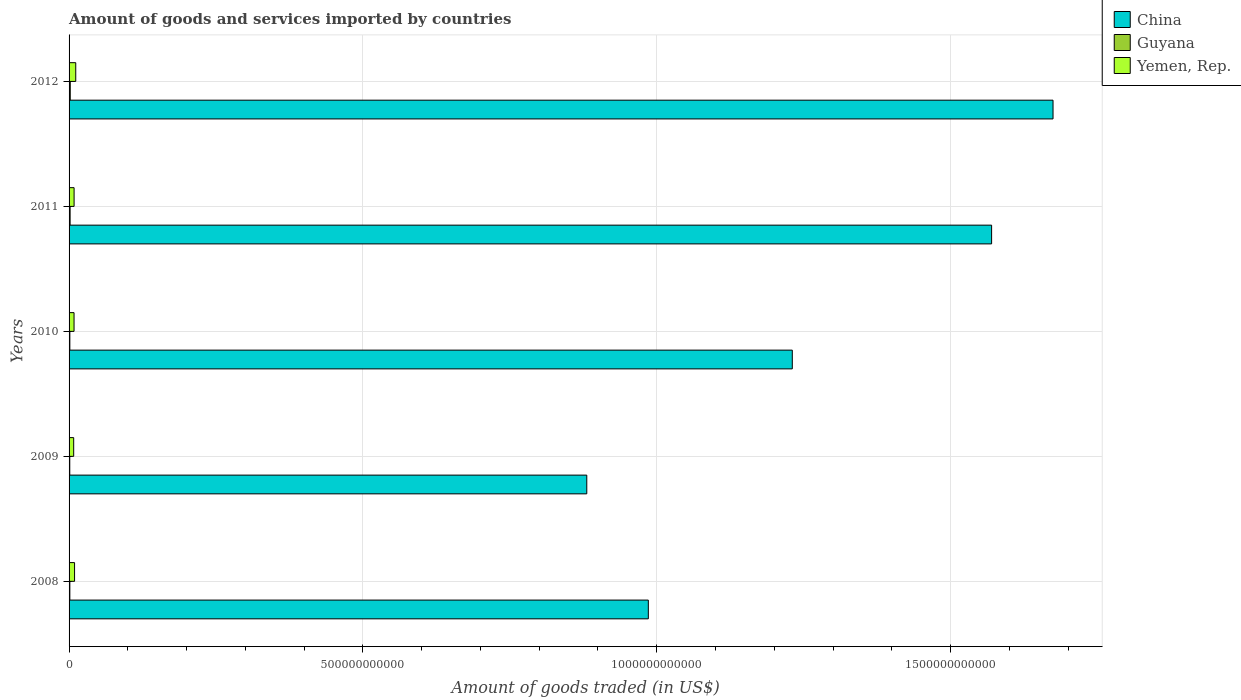Are the number of bars per tick equal to the number of legend labels?
Offer a terse response. Yes. How many bars are there on the 5th tick from the bottom?
Give a very brief answer. 3. What is the total amount of goods and services imported in Guyana in 2012?
Your response must be concise. 2.00e+09. Across all years, what is the maximum total amount of goods and services imported in Guyana?
Your answer should be compact. 2.00e+09. Across all years, what is the minimum total amount of goods and services imported in Guyana?
Make the answer very short. 1.18e+09. In which year was the total amount of goods and services imported in China maximum?
Ensure brevity in your answer.  2012. In which year was the total amount of goods and services imported in China minimum?
Provide a succinct answer. 2009. What is the total total amount of goods and services imported in China in the graph?
Ensure brevity in your answer.  6.34e+12. What is the difference between the total amount of goods and services imported in Yemen, Rep. in 2011 and that in 2012?
Ensure brevity in your answer.  -2.81e+09. What is the difference between the total amount of goods and services imported in Guyana in 2009 and the total amount of goods and services imported in China in 2011?
Your answer should be very brief. -1.57e+12. What is the average total amount of goods and services imported in China per year?
Make the answer very short. 1.27e+12. In the year 2010, what is the difference between the total amount of goods and services imported in China and total amount of goods and services imported in Yemen, Rep.?
Offer a very short reply. 1.22e+12. What is the ratio of the total amount of goods and services imported in Guyana in 2008 to that in 2009?
Your response must be concise. 1.12. Is the total amount of goods and services imported in Yemen, Rep. in 2010 less than that in 2011?
Give a very brief answer. Yes. Is the difference between the total amount of goods and services imported in China in 2009 and 2012 greater than the difference between the total amount of goods and services imported in Yemen, Rep. in 2009 and 2012?
Your answer should be very brief. No. What is the difference between the highest and the second highest total amount of goods and services imported in Yemen, Rep.?
Keep it short and to the point. 2.02e+09. What is the difference between the highest and the lowest total amount of goods and services imported in Guyana?
Your answer should be compact. 8.17e+08. In how many years, is the total amount of goods and services imported in Guyana greater than the average total amount of goods and services imported in Guyana taken over all years?
Your answer should be compact. 2. What does the 3rd bar from the top in 2009 represents?
Offer a terse response. China. What does the 3rd bar from the bottom in 2012 represents?
Keep it short and to the point. Yemen, Rep. What is the difference between two consecutive major ticks on the X-axis?
Ensure brevity in your answer.  5.00e+11. Are the values on the major ticks of X-axis written in scientific E-notation?
Provide a short and direct response. No. Does the graph contain any zero values?
Make the answer very short. No. How many legend labels are there?
Provide a short and direct response. 3. How are the legend labels stacked?
Your answer should be compact. Vertical. What is the title of the graph?
Your answer should be compact. Amount of goods and services imported by countries. Does "Armenia" appear as one of the legend labels in the graph?
Your response must be concise. No. What is the label or title of the X-axis?
Provide a succinct answer. Amount of goods traded (in US$). What is the Amount of goods traded (in US$) of China in 2008?
Your answer should be very brief. 9.86e+11. What is the Amount of goods traded (in US$) of Guyana in 2008?
Give a very brief answer. 1.32e+09. What is the Amount of goods traded (in US$) of Yemen, Rep. in 2008?
Provide a short and direct response. 9.33e+09. What is the Amount of goods traded (in US$) in China in 2009?
Your answer should be very brief. 8.81e+11. What is the Amount of goods traded (in US$) in Guyana in 2009?
Your answer should be compact. 1.18e+09. What is the Amount of goods traded (in US$) in Yemen, Rep. in 2009?
Your answer should be compact. 7.87e+09. What is the Amount of goods traded (in US$) of China in 2010?
Ensure brevity in your answer.  1.23e+12. What is the Amount of goods traded (in US$) of Guyana in 2010?
Your answer should be very brief. 1.31e+09. What is the Amount of goods traded (in US$) in Yemen, Rep. in 2010?
Provide a short and direct response. 8.47e+09. What is the Amount of goods traded (in US$) in China in 2011?
Ensure brevity in your answer.  1.57e+12. What is the Amount of goods traded (in US$) in Guyana in 2011?
Offer a terse response. 1.77e+09. What is the Amount of goods traded (in US$) in Yemen, Rep. in 2011?
Provide a short and direct response. 8.54e+09. What is the Amount of goods traded (in US$) in China in 2012?
Your answer should be very brief. 1.67e+12. What is the Amount of goods traded (in US$) of Guyana in 2012?
Offer a very short reply. 2.00e+09. What is the Amount of goods traded (in US$) in Yemen, Rep. in 2012?
Your answer should be very brief. 1.14e+1. Across all years, what is the maximum Amount of goods traded (in US$) in China?
Keep it short and to the point. 1.67e+12. Across all years, what is the maximum Amount of goods traded (in US$) in Guyana?
Make the answer very short. 2.00e+09. Across all years, what is the maximum Amount of goods traded (in US$) in Yemen, Rep.?
Your answer should be very brief. 1.14e+1. Across all years, what is the minimum Amount of goods traded (in US$) of China?
Your answer should be very brief. 8.81e+11. Across all years, what is the minimum Amount of goods traded (in US$) of Guyana?
Make the answer very short. 1.18e+09. Across all years, what is the minimum Amount of goods traded (in US$) in Yemen, Rep.?
Your answer should be very brief. 7.87e+09. What is the total Amount of goods traded (in US$) in China in the graph?
Make the answer very short. 6.34e+12. What is the total Amount of goods traded (in US$) of Guyana in the graph?
Provide a short and direct response. 7.58e+09. What is the total Amount of goods traded (in US$) of Yemen, Rep. in the graph?
Keep it short and to the point. 4.56e+1. What is the difference between the Amount of goods traded (in US$) of China in 2008 and that in 2009?
Your answer should be very brief. 1.05e+11. What is the difference between the Amount of goods traded (in US$) in Guyana in 2008 and that in 2009?
Provide a succinct answer. 1.44e+08. What is the difference between the Amount of goods traded (in US$) in Yemen, Rep. in 2008 and that in 2009?
Offer a very short reply. 1.47e+09. What is the difference between the Amount of goods traded (in US$) in China in 2008 and that in 2010?
Your answer should be compact. -2.45e+11. What is the difference between the Amount of goods traded (in US$) in Guyana in 2008 and that in 2010?
Provide a short and direct response. 9.89e+06. What is the difference between the Amount of goods traded (in US$) of Yemen, Rep. in 2008 and that in 2010?
Ensure brevity in your answer.  8.61e+08. What is the difference between the Amount of goods traded (in US$) of China in 2008 and that in 2011?
Your response must be concise. -5.84e+11. What is the difference between the Amount of goods traded (in US$) in Guyana in 2008 and that in 2011?
Keep it short and to the point. -4.47e+08. What is the difference between the Amount of goods traded (in US$) in Yemen, Rep. in 2008 and that in 2011?
Offer a very short reply. 7.91e+08. What is the difference between the Amount of goods traded (in US$) of China in 2008 and that in 2012?
Keep it short and to the point. -6.89e+11. What is the difference between the Amount of goods traded (in US$) of Guyana in 2008 and that in 2012?
Your response must be concise. -6.73e+08. What is the difference between the Amount of goods traded (in US$) of Yemen, Rep. in 2008 and that in 2012?
Provide a short and direct response. -2.02e+09. What is the difference between the Amount of goods traded (in US$) in China in 2009 and that in 2010?
Your response must be concise. -3.50e+11. What is the difference between the Amount of goods traded (in US$) in Guyana in 2009 and that in 2010?
Offer a terse response. -1.34e+08. What is the difference between the Amount of goods traded (in US$) in Yemen, Rep. in 2009 and that in 2010?
Offer a very short reply. -6.05e+08. What is the difference between the Amount of goods traded (in US$) in China in 2009 and that in 2011?
Give a very brief answer. -6.89e+11. What is the difference between the Amount of goods traded (in US$) in Guyana in 2009 and that in 2011?
Your answer should be very brief. -5.91e+08. What is the difference between the Amount of goods traded (in US$) in Yemen, Rep. in 2009 and that in 2011?
Keep it short and to the point. -6.75e+08. What is the difference between the Amount of goods traded (in US$) in China in 2009 and that in 2012?
Ensure brevity in your answer.  -7.93e+11. What is the difference between the Amount of goods traded (in US$) of Guyana in 2009 and that in 2012?
Your answer should be compact. -8.17e+08. What is the difference between the Amount of goods traded (in US$) in Yemen, Rep. in 2009 and that in 2012?
Keep it short and to the point. -3.49e+09. What is the difference between the Amount of goods traded (in US$) in China in 2010 and that in 2011?
Your answer should be very brief. -3.39e+11. What is the difference between the Amount of goods traded (in US$) in Guyana in 2010 and that in 2011?
Your response must be concise. -4.57e+08. What is the difference between the Amount of goods traded (in US$) of Yemen, Rep. in 2010 and that in 2011?
Give a very brief answer. -6.96e+07. What is the difference between the Amount of goods traded (in US$) in China in 2010 and that in 2012?
Your answer should be very brief. -4.44e+11. What is the difference between the Amount of goods traded (in US$) of Guyana in 2010 and that in 2012?
Your answer should be compact. -6.83e+08. What is the difference between the Amount of goods traded (in US$) in Yemen, Rep. in 2010 and that in 2012?
Offer a terse response. -2.88e+09. What is the difference between the Amount of goods traded (in US$) of China in 2011 and that in 2012?
Give a very brief answer. -1.05e+11. What is the difference between the Amount of goods traded (in US$) of Guyana in 2011 and that in 2012?
Provide a short and direct response. -2.26e+08. What is the difference between the Amount of goods traded (in US$) in Yemen, Rep. in 2011 and that in 2012?
Give a very brief answer. -2.81e+09. What is the difference between the Amount of goods traded (in US$) of China in 2008 and the Amount of goods traded (in US$) of Guyana in 2009?
Offer a terse response. 9.85e+11. What is the difference between the Amount of goods traded (in US$) of China in 2008 and the Amount of goods traded (in US$) of Yemen, Rep. in 2009?
Ensure brevity in your answer.  9.78e+11. What is the difference between the Amount of goods traded (in US$) in Guyana in 2008 and the Amount of goods traded (in US$) in Yemen, Rep. in 2009?
Make the answer very short. -6.54e+09. What is the difference between the Amount of goods traded (in US$) in China in 2008 and the Amount of goods traded (in US$) in Guyana in 2010?
Give a very brief answer. 9.84e+11. What is the difference between the Amount of goods traded (in US$) in China in 2008 and the Amount of goods traded (in US$) in Yemen, Rep. in 2010?
Your answer should be compact. 9.77e+11. What is the difference between the Amount of goods traded (in US$) in Guyana in 2008 and the Amount of goods traded (in US$) in Yemen, Rep. in 2010?
Your answer should be compact. -7.15e+09. What is the difference between the Amount of goods traded (in US$) in China in 2008 and the Amount of goods traded (in US$) in Guyana in 2011?
Your response must be concise. 9.84e+11. What is the difference between the Amount of goods traded (in US$) of China in 2008 and the Amount of goods traded (in US$) of Yemen, Rep. in 2011?
Provide a succinct answer. 9.77e+11. What is the difference between the Amount of goods traded (in US$) of Guyana in 2008 and the Amount of goods traded (in US$) of Yemen, Rep. in 2011?
Provide a succinct answer. -7.22e+09. What is the difference between the Amount of goods traded (in US$) of China in 2008 and the Amount of goods traded (in US$) of Guyana in 2012?
Offer a very short reply. 9.84e+11. What is the difference between the Amount of goods traded (in US$) in China in 2008 and the Amount of goods traded (in US$) in Yemen, Rep. in 2012?
Offer a terse response. 9.74e+11. What is the difference between the Amount of goods traded (in US$) of Guyana in 2008 and the Amount of goods traded (in US$) of Yemen, Rep. in 2012?
Offer a very short reply. -1.00e+1. What is the difference between the Amount of goods traded (in US$) in China in 2009 and the Amount of goods traded (in US$) in Guyana in 2010?
Provide a succinct answer. 8.80e+11. What is the difference between the Amount of goods traded (in US$) in China in 2009 and the Amount of goods traded (in US$) in Yemen, Rep. in 2010?
Provide a short and direct response. 8.72e+11. What is the difference between the Amount of goods traded (in US$) of Guyana in 2009 and the Amount of goods traded (in US$) of Yemen, Rep. in 2010?
Provide a succinct answer. -7.29e+09. What is the difference between the Amount of goods traded (in US$) of China in 2009 and the Amount of goods traded (in US$) of Guyana in 2011?
Offer a very short reply. 8.79e+11. What is the difference between the Amount of goods traded (in US$) in China in 2009 and the Amount of goods traded (in US$) in Yemen, Rep. in 2011?
Your answer should be very brief. 8.72e+11. What is the difference between the Amount of goods traded (in US$) of Guyana in 2009 and the Amount of goods traded (in US$) of Yemen, Rep. in 2011?
Make the answer very short. -7.36e+09. What is the difference between the Amount of goods traded (in US$) in China in 2009 and the Amount of goods traded (in US$) in Guyana in 2012?
Provide a succinct answer. 8.79e+11. What is the difference between the Amount of goods traded (in US$) of China in 2009 and the Amount of goods traded (in US$) of Yemen, Rep. in 2012?
Give a very brief answer. 8.70e+11. What is the difference between the Amount of goods traded (in US$) of Guyana in 2009 and the Amount of goods traded (in US$) of Yemen, Rep. in 2012?
Your response must be concise. -1.02e+1. What is the difference between the Amount of goods traded (in US$) in China in 2010 and the Amount of goods traded (in US$) in Guyana in 2011?
Your answer should be very brief. 1.23e+12. What is the difference between the Amount of goods traded (in US$) of China in 2010 and the Amount of goods traded (in US$) of Yemen, Rep. in 2011?
Offer a very short reply. 1.22e+12. What is the difference between the Amount of goods traded (in US$) of Guyana in 2010 and the Amount of goods traded (in US$) of Yemen, Rep. in 2011?
Your answer should be very brief. -7.23e+09. What is the difference between the Amount of goods traded (in US$) in China in 2010 and the Amount of goods traded (in US$) in Guyana in 2012?
Make the answer very short. 1.23e+12. What is the difference between the Amount of goods traded (in US$) in China in 2010 and the Amount of goods traded (in US$) in Yemen, Rep. in 2012?
Ensure brevity in your answer.  1.22e+12. What is the difference between the Amount of goods traded (in US$) in Guyana in 2010 and the Amount of goods traded (in US$) in Yemen, Rep. in 2012?
Your response must be concise. -1.00e+1. What is the difference between the Amount of goods traded (in US$) in China in 2011 and the Amount of goods traded (in US$) in Guyana in 2012?
Give a very brief answer. 1.57e+12. What is the difference between the Amount of goods traded (in US$) of China in 2011 and the Amount of goods traded (in US$) of Yemen, Rep. in 2012?
Your response must be concise. 1.56e+12. What is the difference between the Amount of goods traded (in US$) in Guyana in 2011 and the Amount of goods traded (in US$) in Yemen, Rep. in 2012?
Keep it short and to the point. -9.58e+09. What is the average Amount of goods traded (in US$) of China per year?
Your answer should be compact. 1.27e+12. What is the average Amount of goods traded (in US$) of Guyana per year?
Ensure brevity in your answer.  1.52e+09. What is the average Amount of goods traded (in US$) of Yemen, Rep. per year?
Keep it short and to the point. 9.11e+09. In the year 2008, what is the difference between the Amount of goods traded (in US$) in China and Amount of goods traded (in US$) in Guyana?
Keep it short and to the point. 9.84e+11. In the year 2008, what is the difference between the Amount of goods traded (in US$) of China and Amount of goods traded (in US$) of Yemen, Rep.?
Provide a short and direct response. 9.76e+11. In the year 2008, what is the difference between the Amount of goods traded (in US$) in Guyana and Amount of goods traded (in US$) in Yemen, Rep.?
Your response must be concise. -8.01e+09. In the year 2009, what is the difference between the Amount of goods traded (in US$) in China and Amount of goods traded (in US$) in Guyana?
Your answer should be very brief. 8.80e+11. In the year 2009, what is the difference between the Amount of goods traded (in US$) of China and Amount of goods traded (in US$) of Yemen, Rep.?
Offer a very short reply. 8.73e+11. In the year 2009, what is the difference between the Amount of goods traded (in US$) of Guyana and Amount of goods traded (in US$) of Yemen, Rep.?
Provide a short and direct response. -6.69e+09. In the year 2010, what is the difference between the Amount of goods traded (in US$) in China and Amount of goods traded (in US$) in Guyana?
Keep it short and to the point. 1.23e+12. In the year 2010, what is the difference between the Amount of goods traded (in US$) in China and Amount of goods traded (in US$) in Yemen, Rep.?
Your answer should be very brief. 1.22e+12. In the year 2010, what is the difference between the Amount of goods traded (in US$) of Guyana and Amount of goods traded (in US$) of Yemen, Rep.?
Keep it short and to the point. -7.16e+09. In the year 2011, what is the difference between the Amount of goods traded (in US$) of China and Amount of goods traded (in US$) of Guyana?
Keep it short and to the point. 1.57e+12. In the year 2011, what is the difference between the Amount of goods traded (in US$) of China and Amount of goods traded (in US$) of Yemen, Rep.?
Offer a terse response. 1.56e+12. In the year 2011, what is the difference between the Amount of goods traded (in US$) in Guyana and Amount of goods traded (in US$) in Yemen, Rep.?
Provide a short and direct response. -6.77e+09. In the year 2012, what is the difference between the Amount of goods traded (in US$) of China and Amount of goods traded (in US$) of Guyana?
Keep it short and to the point. 1.67e+12. In the year 2012, what is the difference between the Amount of goods traded (in US$) in China and Amount of goods traded (in US$) in Yemen, Rep.?
Keep it short and to the point. 1.66e+12. In the year 2012, what is the difference between the Amount of goods traded (in US$) of Guyana and Amount of goods traded (in US$) of Yemen, Rep.?
Give a very brief answer. -9.36e+09. What is the ratio of the Amount of goods traded (in US$) in China in 2008 to that in 2009?
Make the answer very short. 1.12. What is the ratio of the Amount of goods traded (in US$) in Guyana in 2008 to that in 2009?
Offer a terse response. 1.12. What is the ratio of the Amount of goods traded (in US$) in Yemen, Rep. in 2008 to that in 2009?
Make the answer very short. 1.19. What is the ratio of the Amount of goods traded (in US$) in China in 2008 to that in 2010?
Your answer should be very brief. 0.8. What is the ratio of the Amount of goods traded (in US$) in Guyana in 2008 to that in 2010?
Provide a succinct answer. 1.01. What is the ratio of the Amount of goods traded (in US$) in Yemen, Rep. in 2008 to that in 2010?
Keep it short and to the point. 1.1. What is the ratio of the Amount of goods traded (in US$) in China in 2008 to that in 2011?
Keep it short and to the point. 0.63. What is the ratio of the Amount of goods traded (in US$) of Guyana in 2008 to that in 2011?
Provide a short and direct response. 0.75. What is the ratio of the Amount of goods traded (in US$) of Yemen, Rep. in 2008 to that in 2011?
Your answer should be compact. 1.09. What is the ratio of the Amount of goods traded (in US$) of China in 2008 to that in 2012?
Offer a very short reply. 0.59. What is the ratio of the Amount of goods traded (in US$) in Guyana in 2008 to that in 2012?
Your answer should be very brief. 0.66. What is the ratio of the Amount of goods traded (in US$) in Yemen, Rep. in 2008 to that in 2012?
Offer a very short reply. 0.82. What is the ratio of the Amount of goods traded (in US$) in China in 2009 to that in 2010?
Provide a succinct answer. 0.72. What is the ratio of the Amount of goods traded (in US$) in Guyana in 2009 to that in 2010?
Provide a succinct answer. 0.9. What is the ratio of the Amount of goods traded (in US$) in China in 2009 to that in 2011?
Offer a terse response. 0.56. What is the ratio of the Amount of goods traded (in US$) of Guyana in 2009 to that in 2011?
Your answer should be compact. 0.67. What is the ratio of the Amount of goods traded (in US$) in Yemen, Rep. in 2009 to that in 2011?
Offer a terse response. 0.92. What is the ratio of the Amount of goods traded (in US$) of China in 2009 to that in 2012?
Provide a succinct answer. 0.53. What is the ratio of the Amount of goods traded (in US$) in Guyana in 2009 to that in 2012?
Your answer should be very brief. 0.59. What is the ratio of the Amount of goods traded (in US$) of Yemen, Rep. in 2009 to that in 2012?
Provide a succinct answer. 0.69. What is the ratio of the Amount of goods traded (in US$) of China in 2010 to that in 2011?
Offer a terse response. 0.78. What is the ratio of the Amount of goods traded (in US$) of Guyana in 2010 to that in 2011?
Keep it short and to the point. 0.74. What is the ratio of the Amount of goods traded (in US$) in China in 2010 to that in 2012?
Your answer should be very brief. 0.73. What is the ratio of the Amount of goods traded (in US$) in Guyana in 2010 to that in 2012?
Offer a terse response. 0.66. What is the ratio of the Amount of goods traded (in US$) of Yemen, Rep. in 2010 to that in 2012?
Ensure brevity in your answer.  0.75. What is the ratio of the Amount of goods traded (in US$) of China in 2011 to that in 2012?
Offer a terse response. 0.94. What is the ratio of the Amount of goods traded (in US$) of Guyana in 2011 to that in 2012?
Provide a succinct answer. 0.89. What is the ratio of the Amount of goods traded (in US$) of Yemen, Rep. in 2011 to that in 2012?
Offer a very short reply. 0.75. What is the difference between the highest and the second highest Amount of goods traded (in US$) in China?
Make the answer very short. 1.05e+11. What is the difference between the highest and the second highest Amount of goods traded (in US$) in Guyana?
Your response must be concise. 2.26e+08. What is the difference between the highest and the second highest Amount of goods traded (in US$) in Yemen, Rep.?
Make the answer very short. 2.02e+09. What is the difference between the highest and the lowest Amount of goods traded (in US$) in China?
Your response must be concise. 7.93e+11. What is the difference between the highest and the lowest Amount of goods traded (in US$) of Guyana?
Offer a terse response. 8.17e+08. What is the difference between the highest and the lowest Amount of goods traded (in US$) in Yemen, Rep.?
Your answer should be very brief. 3.49e+09. 